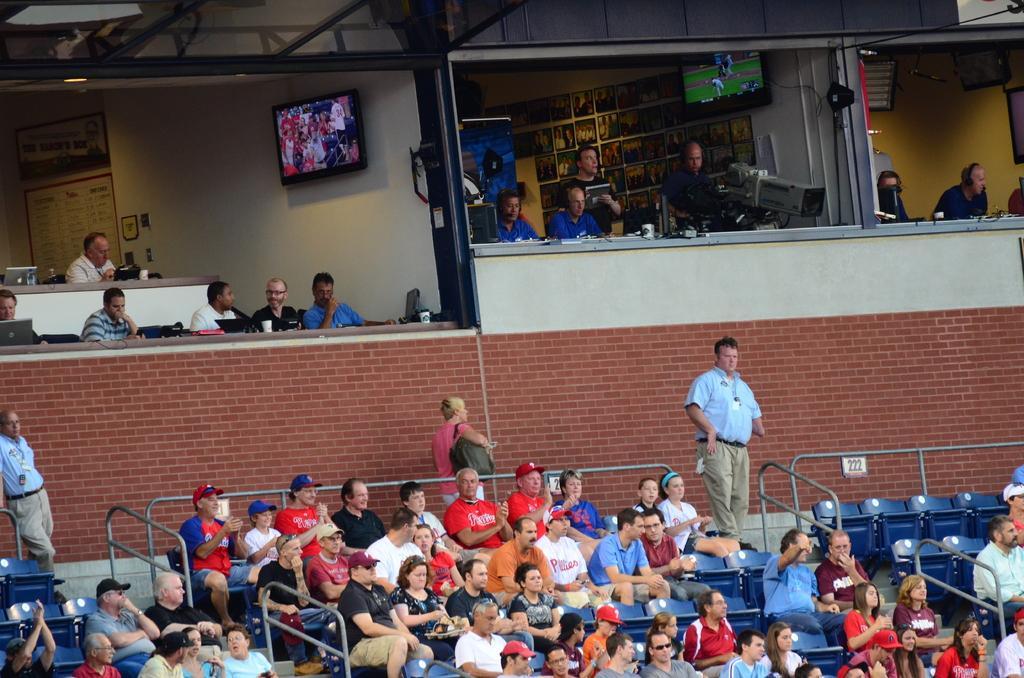Describe this image in one or two sentences. In the foreground of the image we can see a group of people sitting in chairs, metal railing, some persons are standing. One woman is carrying a bag. In the background of the image we can see a person holding a camera in his hand, a group of people, two screens, group of people and some lights. 